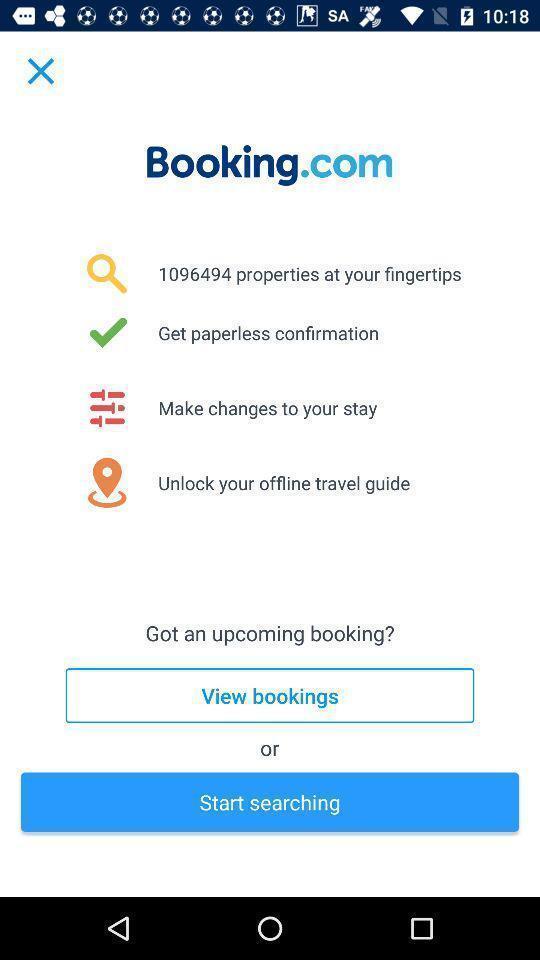Describe the key features of this screenshot. Screen page displaying various options. 